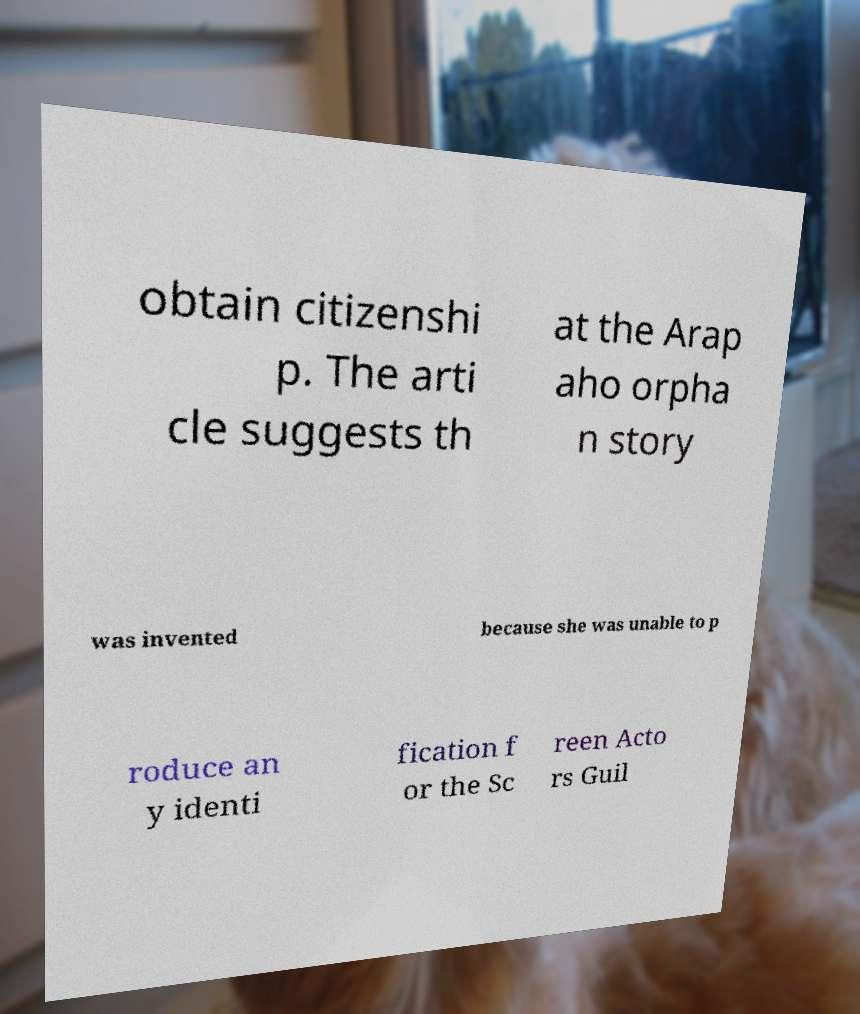Can you accurately transcribe the text from the provided image for me? obtain citizenshi p. The arti cle suggests th at the Arap aho orpha n story was invented because she was unable to p roduce an y identi fication f or the Sc reen Acto rs Guil 